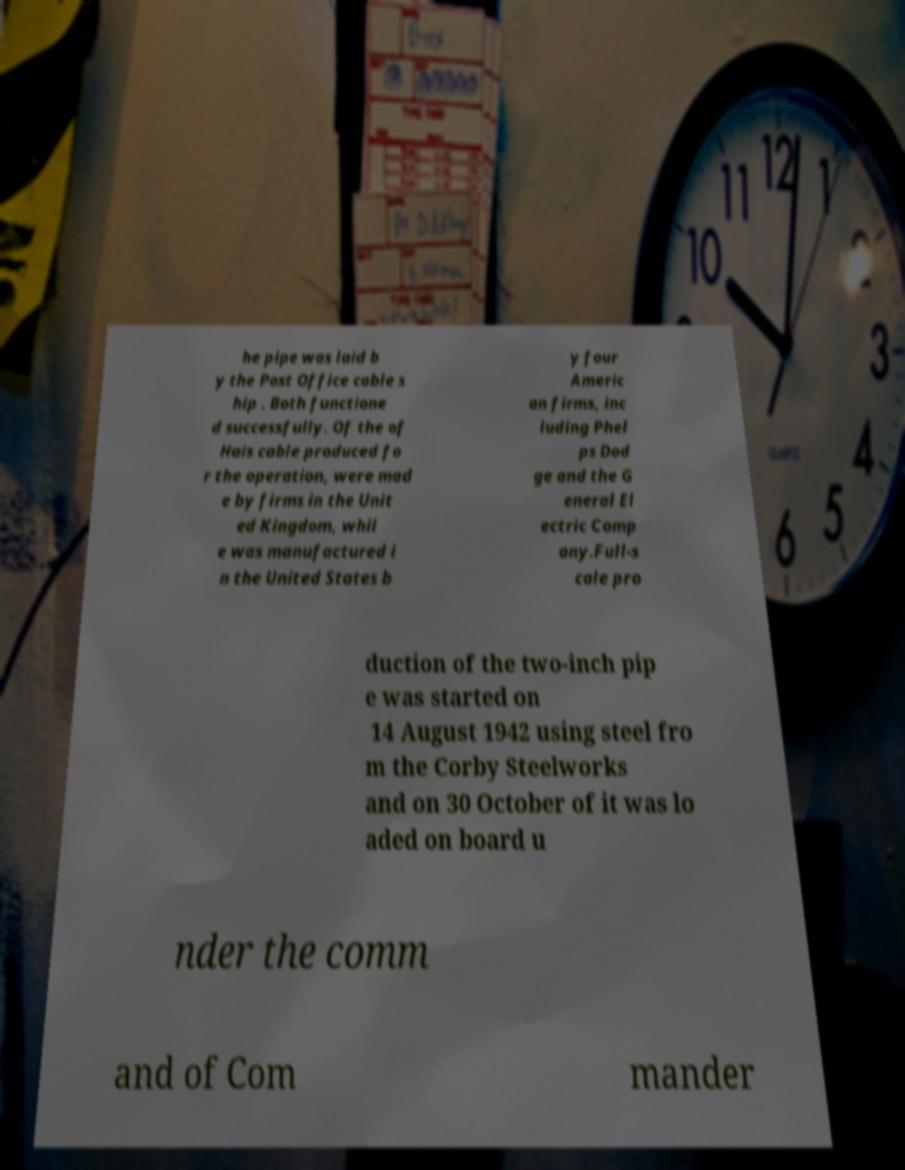For documentation purposes, I need the text within this image transcribed. Could you provide that? he pipe was laid b y the Post Office cable s hip . Both functione d successfully. Of the of Hais cable produced fo r the operation, were mad e by firms in the Unit ed Kingdom, whil e was manufactured i n the United States b y four Americ an firms, inc luding Phel ps Dod ge and the G eneral El ectric Comp any.Full-s cale pro duction of the two-inch pip e was started on 14 August 1942 using steel fro m the Corby Steelworks and on 30 October of it was lo aded on board u nder the comm and of Com mander 